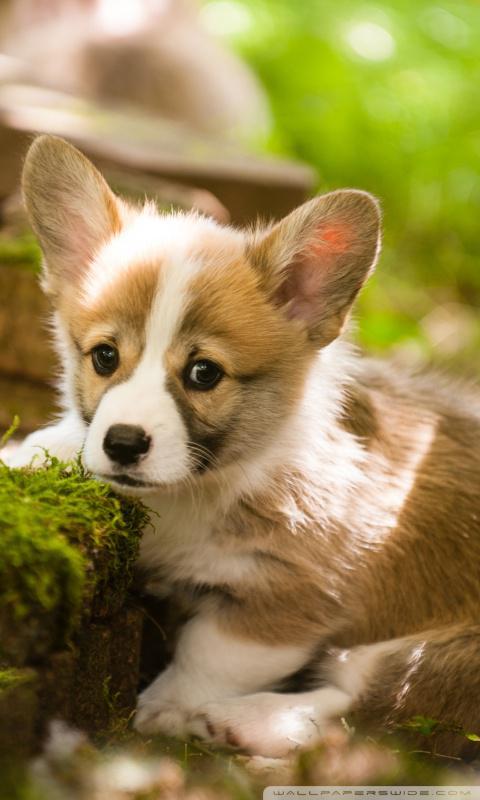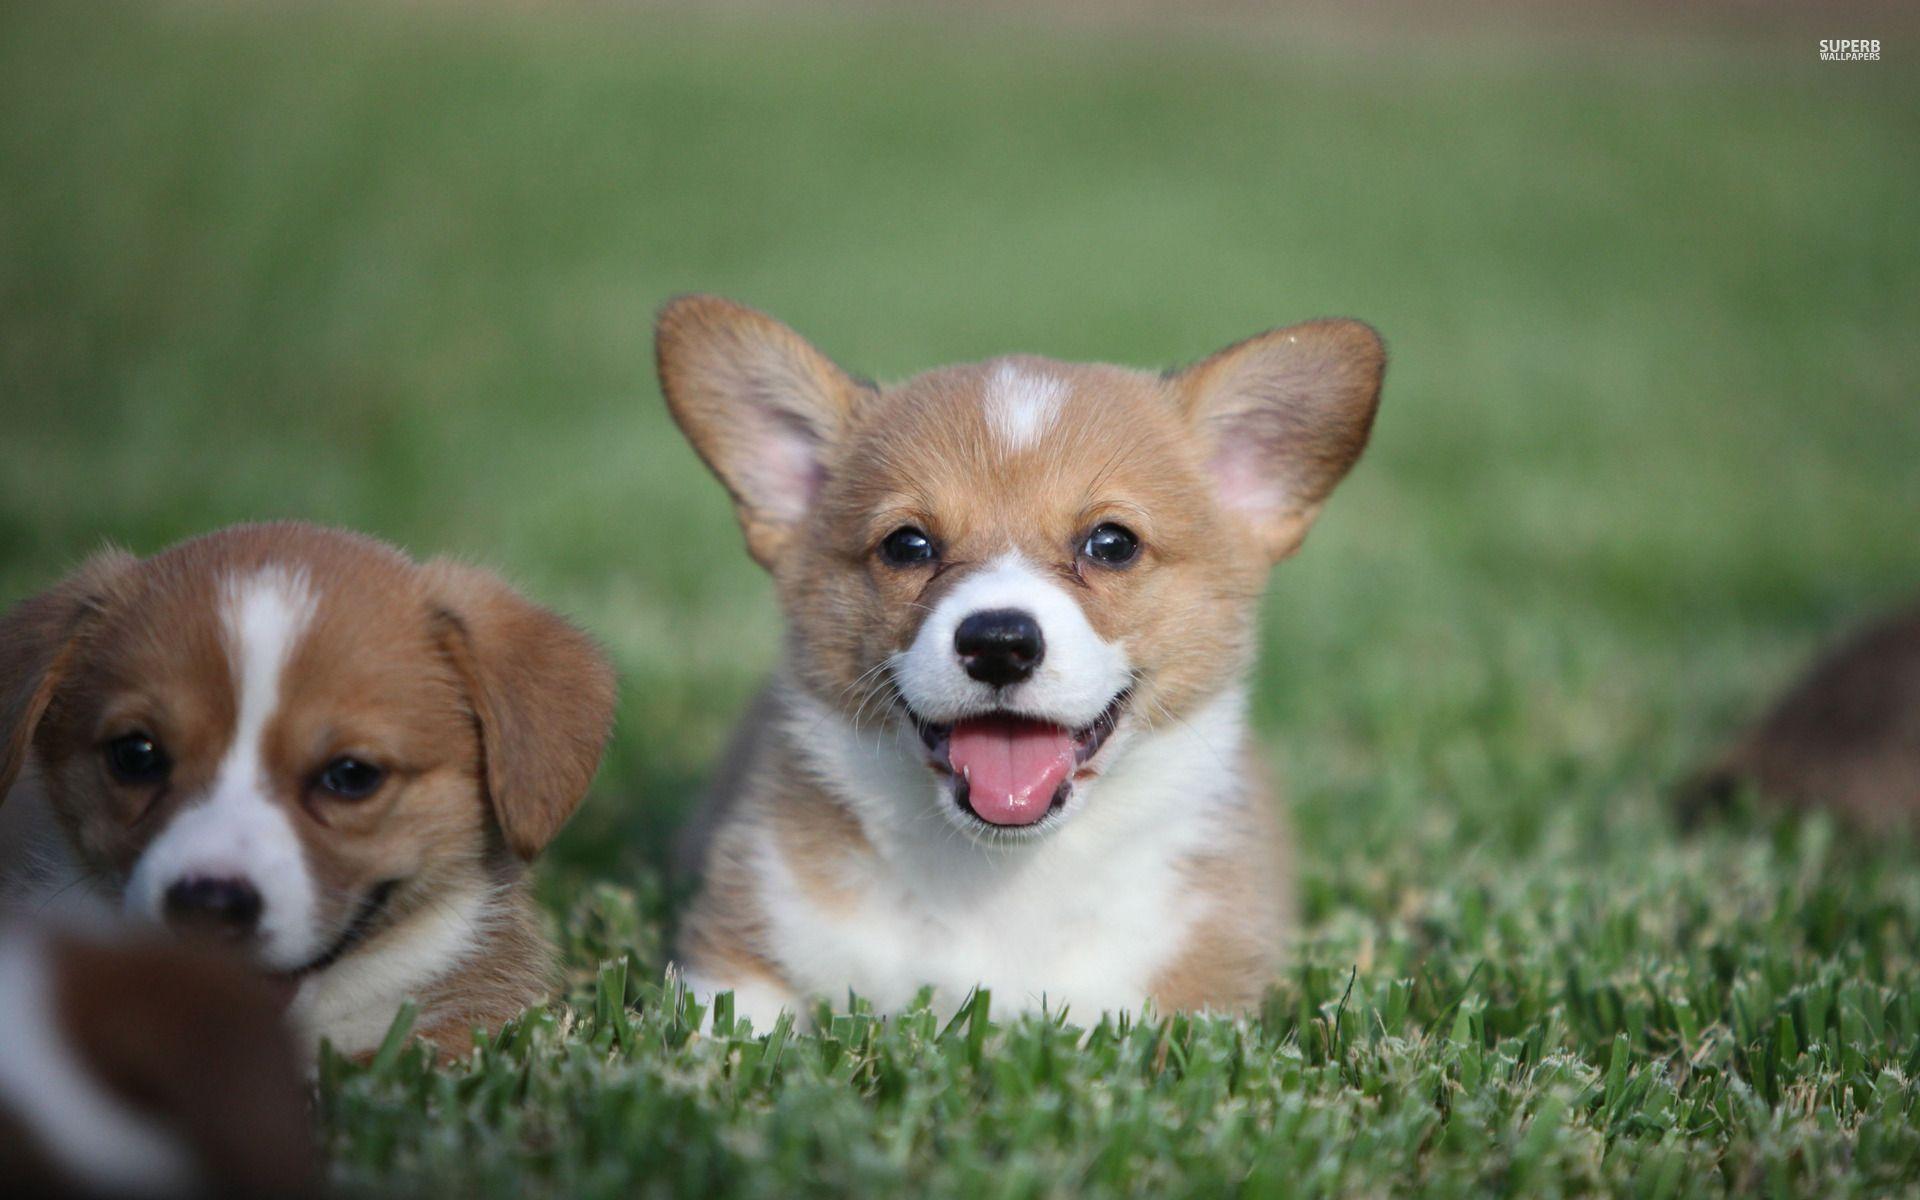The first image is the image on the left, the second image is the image on the right. Assess this claim about the two images: "Two dogs are lying in the grass in the image on the right.". Correct or not? Answer yes or no. Yes. The first image is the image on the left, the second image is the image on the right. Considering the images on both sides, is "The right image contains exactly two dogs." valid? Answer yes or no. Yes. 